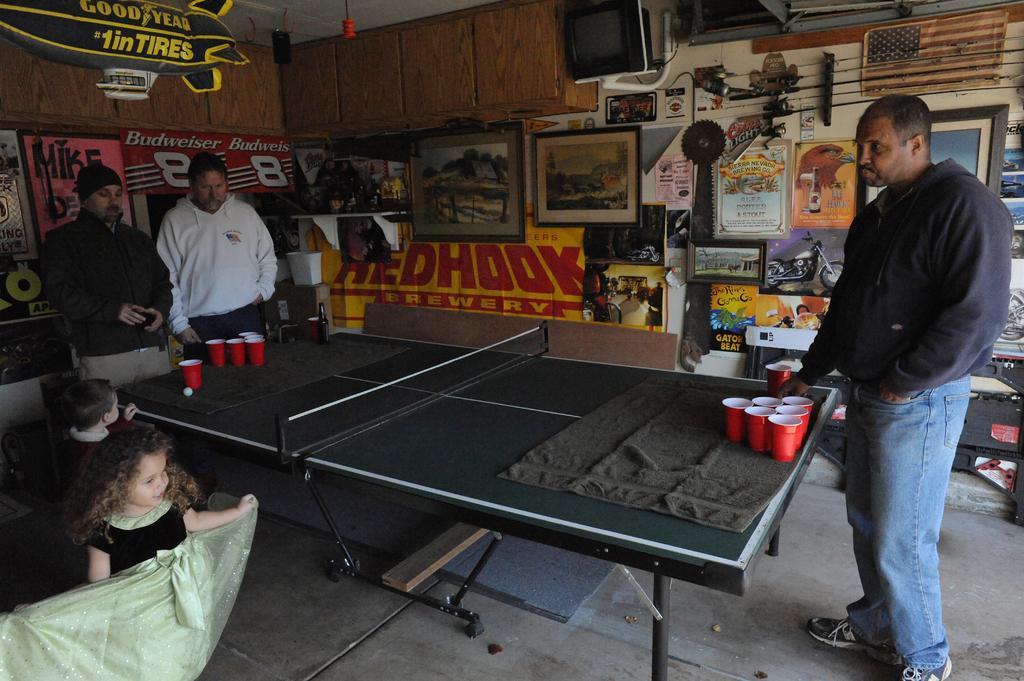Please provide a concise description of this image. In this picture there are three people standing around the table on which there are some glasses and beside the table there are two children and to the left side wall there are frames and a screen. 